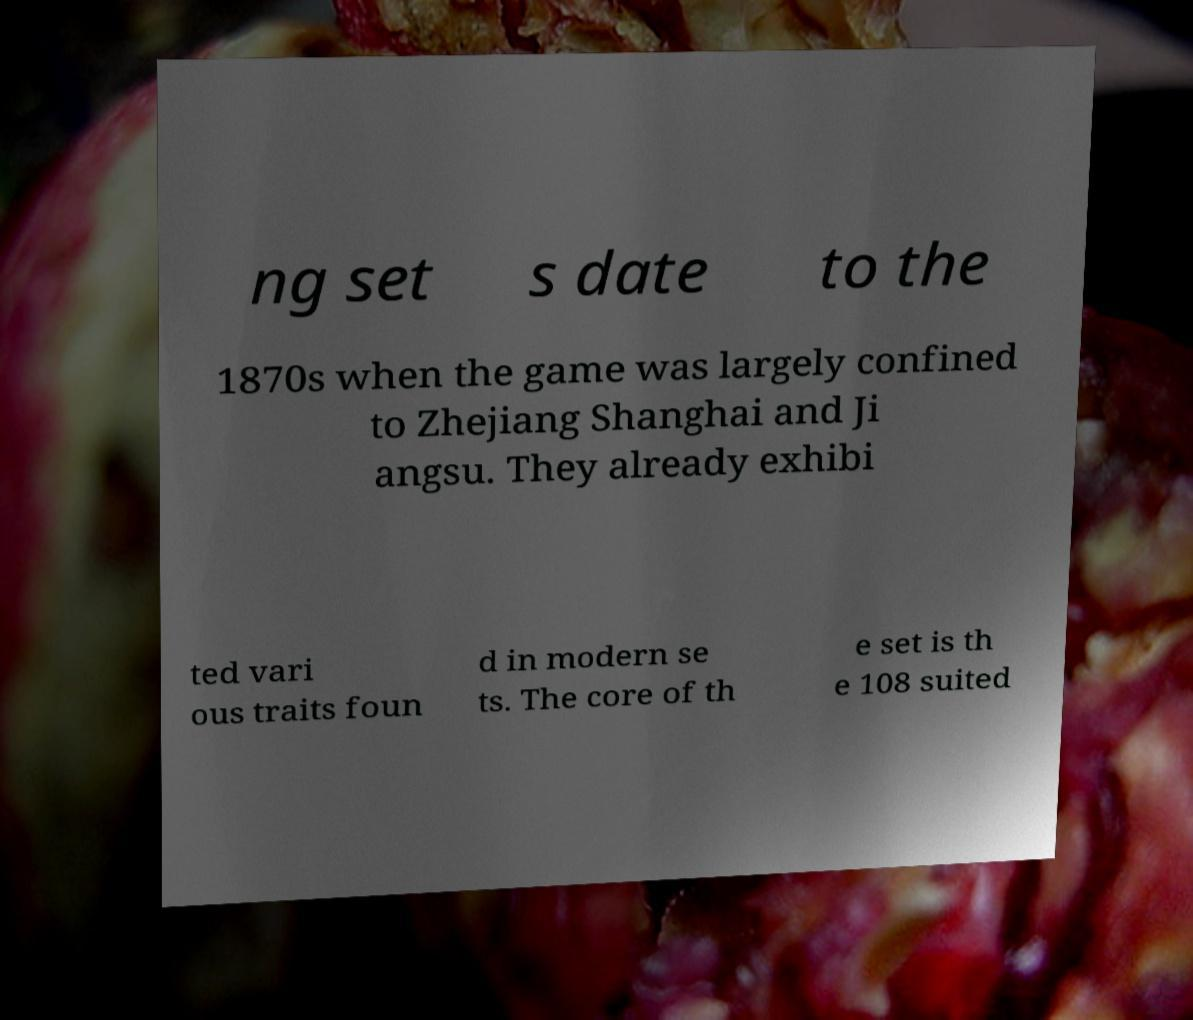What messages or text are displayed in this image? I need them in a readable, typed format. ng set s date to the 1870s when the game was largely confined to Zhejiang Shanghai and Ji angsu. They already exhibi ted vari ous traits foun d in modern se ts. The core of th e set is th e 108 suited 